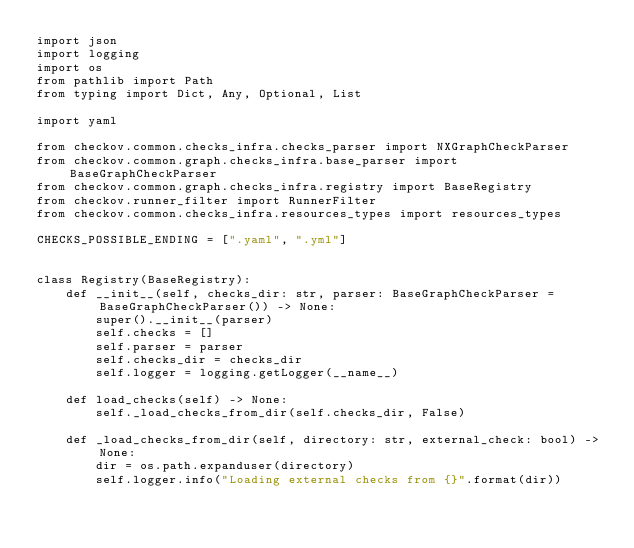Convert code to text. <code><loc_0><loc_0><loc_500><loc_500><_Python_>import json
import logging
import os
from pathlib import Path
from typing import Dict, Any, Optional, List

import yaml

from checkov.common.checks_infra.checks_parser import NXGraphCheckParser
from checkov.common.graph.checks_infra.base_parser import BaseGraphCheckParser
from checkov.common.graph.checks_infra.registry import BaseRegistry
from checkov.runner_filter import RunnerFilter
from checkov.common.checks_infra.resources_types import resources_types

CHECKS_POSSIBLE_ENDING = [".yaml", ".yml"]


class Registry(BaseRegistry):
    def __init__(self, checks_dir: str, parser: BaseGraphCheckParser = BaseGraphCheckParser()) -> None:
        super().__init__(parser)
        self.checks = []
        self.parser = parser
        self.checks_dir = checks_dir
        self.logger = logging.getLogger(__name__)

    def load_checks(self) -> None:
        self._load_checks_from_dir(self.checks_dir, False)

    def _load_checks_from_dir(self, directory: str, external_check: bool) -> None:
        dir = os.path.expanduser(directory)
        self.logger.info("Loading external checks from {}".format(dir))</code> 